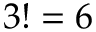Convert formula to latex. <formula><loc_0><loc_0><loc_500><loc_500>3 ! = 6</formula> 